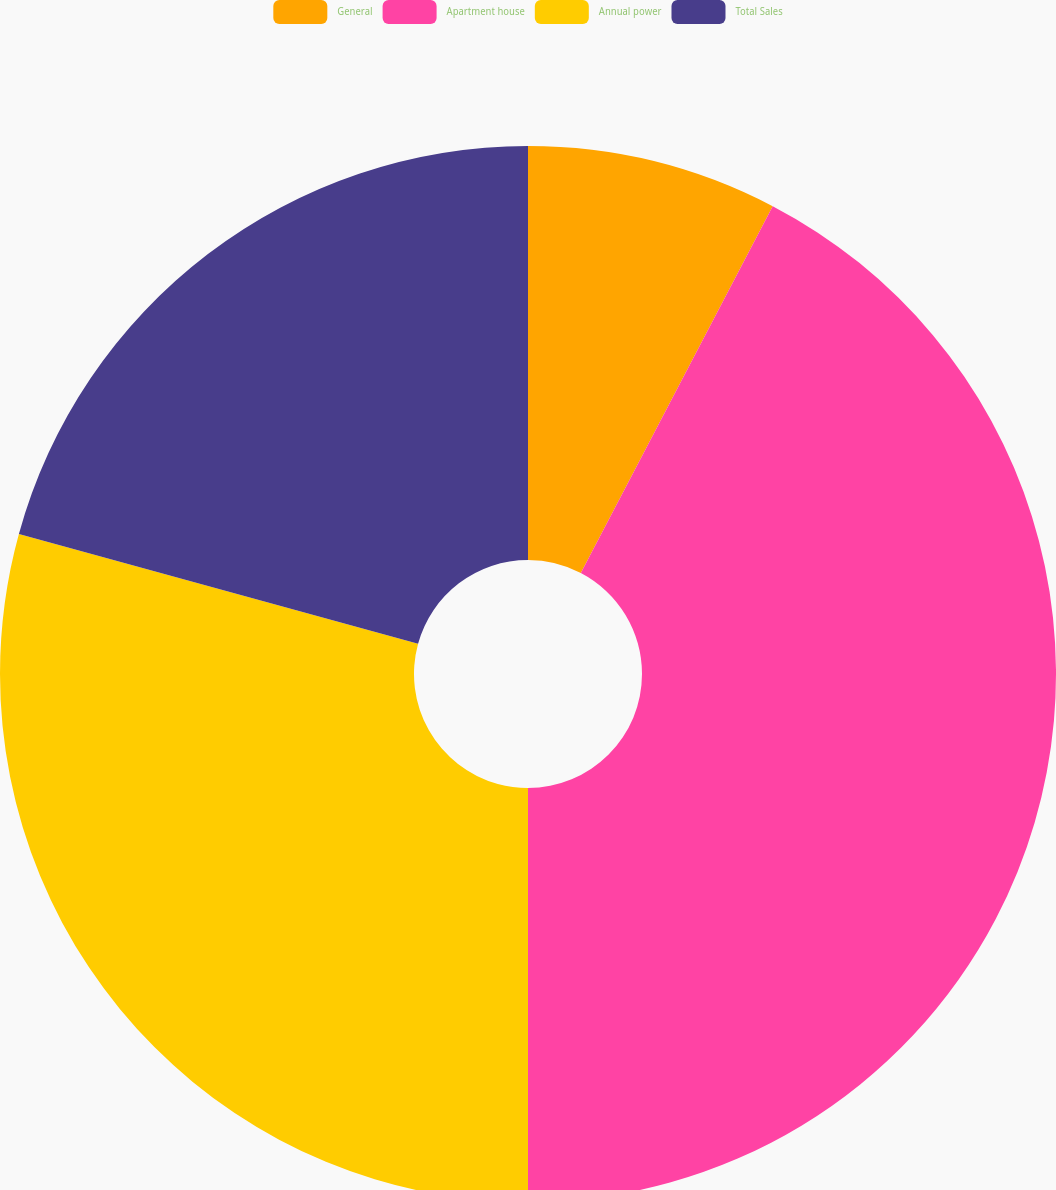<chart> <loc_0><loc_0><loc_500><loc_500><pie_chart><fcel>General<fcel>Apartment house<fcel>Annual power<fcel>Total Sales<nl><fcel>7.67%<fcel>42.33%<fcel>29.27%<fcel>20.73%<nl></chart> 